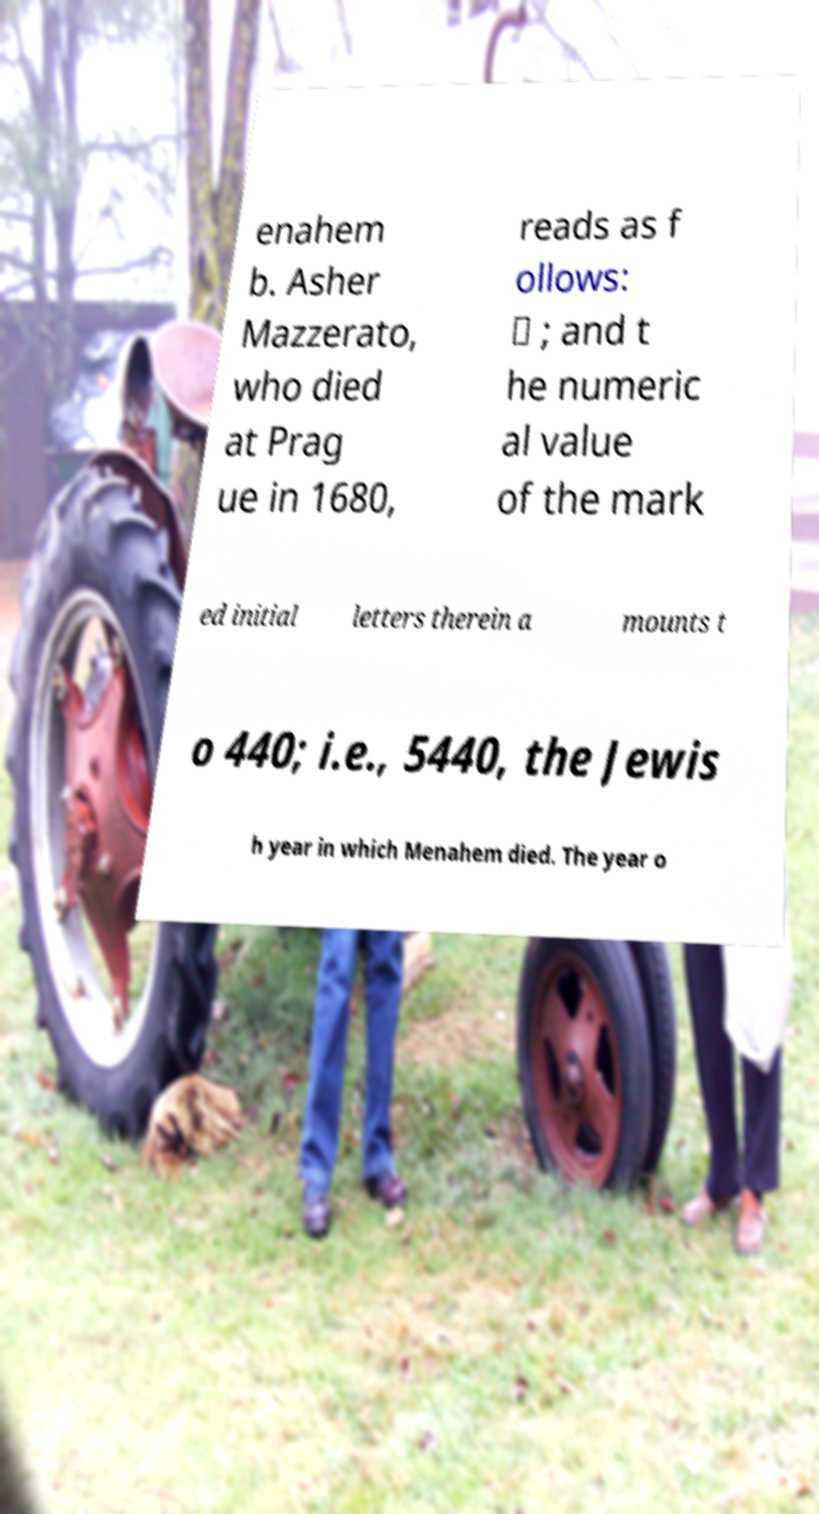I need the written content from this picture converted into text. Can you do that? enahem b. Asher Mazzerato, who died at Prag ue in 1680, reads as f ollows: ״ ; and t he numeric al value of the mark ed initial letters therein a mounts t o 440; i.e., 5440, the Jewis h year in which Menahem died. The year o 